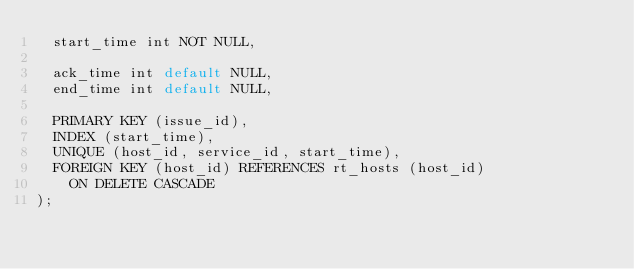<code> <loc_0><loc_0><loc_500><loc_500><_SQL_>  start_time int NOT NULL,

  ack_time int default NULL,
  end_time int default NULL,

  PRIMARY KEY (issue_id),
  INDEX (start_time),
  UNIQUE (host_id, service_id, start_time),
  FOREIGN KEY (host_id) REFERENCES rt_hosts (host_id)
    ON DELETE CASCADE
);
</code> 